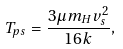<formula> <loc_0><loc_0><loc_500><loc_500>T _ { p s } = \frac { 3 \mu m _ { H } v _ { s } ^ { 2 } } { 1 6 k } ,</formula> 